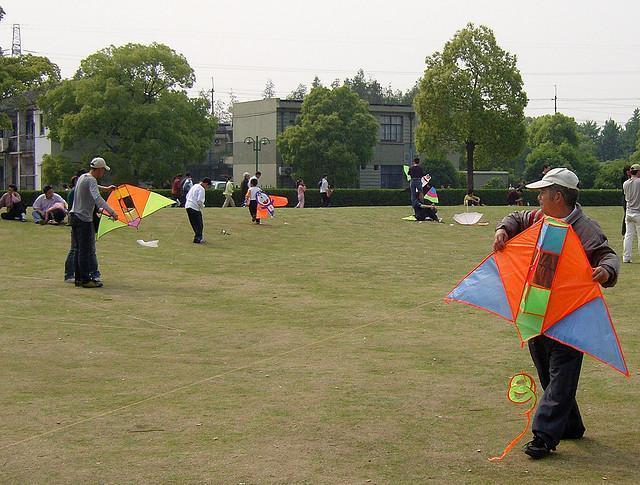How many people are holding a kite in this scene?
Give a very brief answer. 4. How many kites can be seen?
Give a very brief answer. 2. How many people are visible?
Give a very brief answer. 3. How many dogs have a frisbee in their mouth?
Give a very brief answer. 0. 